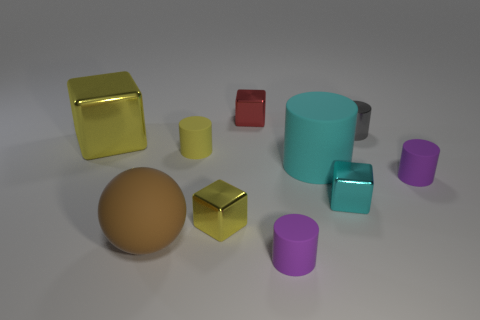What number of cyan shiny things are there?
Offer a very short reply. 1. What number of yellow things are the same size as the cyan metallic block?
Provide a short and direct response. 2. What is the cyan cylinder made of?
Your answer should be compact. Rubber. Do the sphere and the tiny metallic cube behind the large cyan object have the same color?
Provide a succinct answer. No. Are there any other things that are the same size as the cyan metallic thing?
Keep it short and to the point. Yes. There is a rubber object that is both on the left side of the red metallic object and behind the brown thing; what size is it?
Your response must be concise. Small. There is a small gray thing that is made of the same material as the small red thing; what is its shape?
Your answer should be compact. Cylinder. Are the small gray thing and the yellow block that is behind the yellow matte cylinder made of the same material?
Your answer should be compact. Yes. Are there any tiny purple matte cylinders that are behind the big rubber object behind the large rubber ball?
Your answer should be compact. No. There is a big cyan thing that is the same shape as the small gray shiny thing; what is its material?
Your response must be concise. Rubber. 